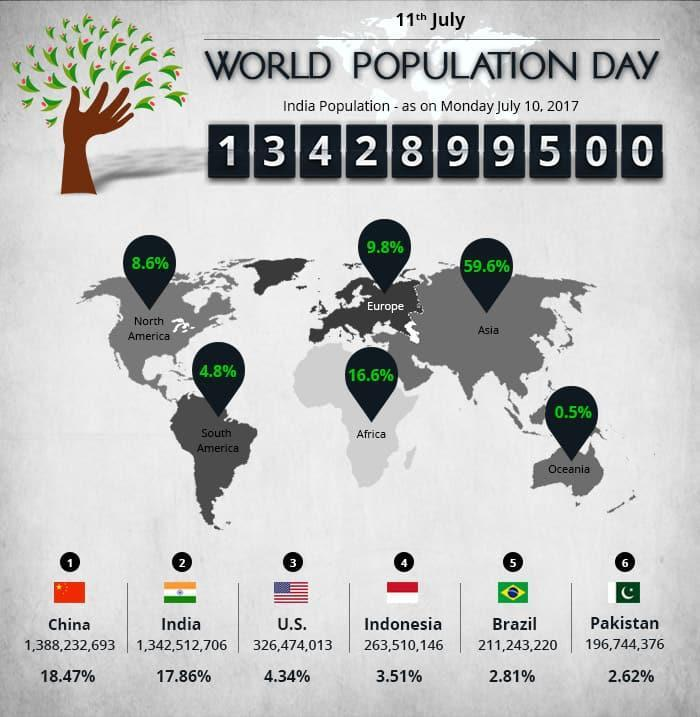what is the total percentage of population of India and Pakistan taken together?
Answer the question with a short phrase. 20.48% what is the total percentage of population of India and China taken together? 36.33% which continent is the least populous? Oceania what is the total percentage of population of Europe and Africa taken together? 26.4 which continent is the second most populous? Africa which continent is more populous among North America and South America? North America which continent is the most populous? Asia what is the total percentage of population of North America and South America taken together? 13.4% what is the total percentage of population of Asia and Europe taken together? 69.4% which continent is more populous among Africa and Europe? Africa 